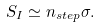Convert formula to latex. <formula><loc_0><loc_0><loc_500><loc_500>S _ { I } \simeq n _ { s t e p } \sigma .</formula> 